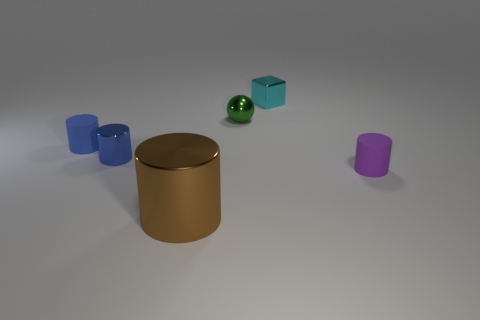Subtract all brown cylinders. How many cylinders are left? 3 Add 1 purple matte objects. How many objects exist? 7 Subtract all purple balls. How many blue cylinders are left? 2 Subtract all purple cylinders. How many cylinders are left? 3 Subtract all cubes. How many objects are left? 5 Subtract 3 cylinders. How many cylinders are left? 1 Add 3 green metal objects. How many green metal objects are left? 4 Add 5 cyan metallic cubes. How many cyan metallic cubes exist? 6 Subtract 1 green balls. How many objects are left? 5 Subtract all cyan balls. Subtract all cyan cylinders. How many balls are left? 1 